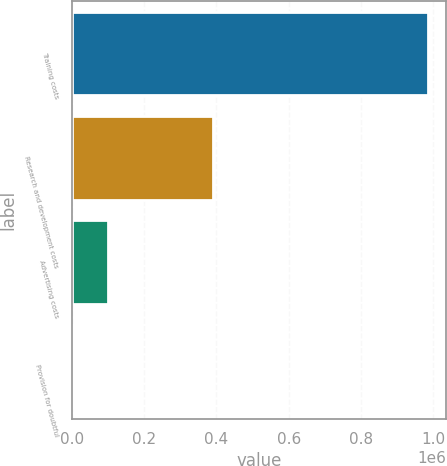<chart> <loc_0><loc_0><loc_500><loc_500><bar_chart><fcel>Training costs<fcel>Research and development costs<fcel>Advertising costs<fcel>Provision for doubtful<nl><fcel>985929<fcel>390168<fcel>100188<fcel>1772<nl></chart> 